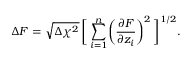<formula> <loc_0><loc_0><loc_500><loc_500>\Delta F = \sqrt { \Delta \chi ^ { 2 } } \, \left [ \, \sum _ { i = 1 } ^ { n } \left ( \frac { \partial F } { \partial z _ { i } } \right ) ^ { 2 } \, \right ] ^ { 1 / 2 } .</formula> 